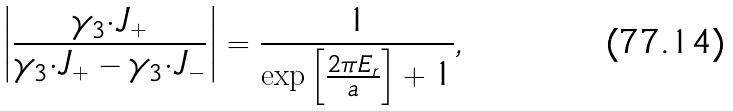<formula> <loc_0><loc_0><loc_500><loc_500>\left | \frac { \gamma _ { 3 } { \cdot } J _ { + } } { \gamma _ { 3 } { \cdot } J _ { + } - \gamma _ { 3 } { \cdot } J _ { - } } \right | = \frac { 1 } { \exp \left [ \frac { 2 \pi E _ { r } } { a } \right ] + 1 } ,</formula> 